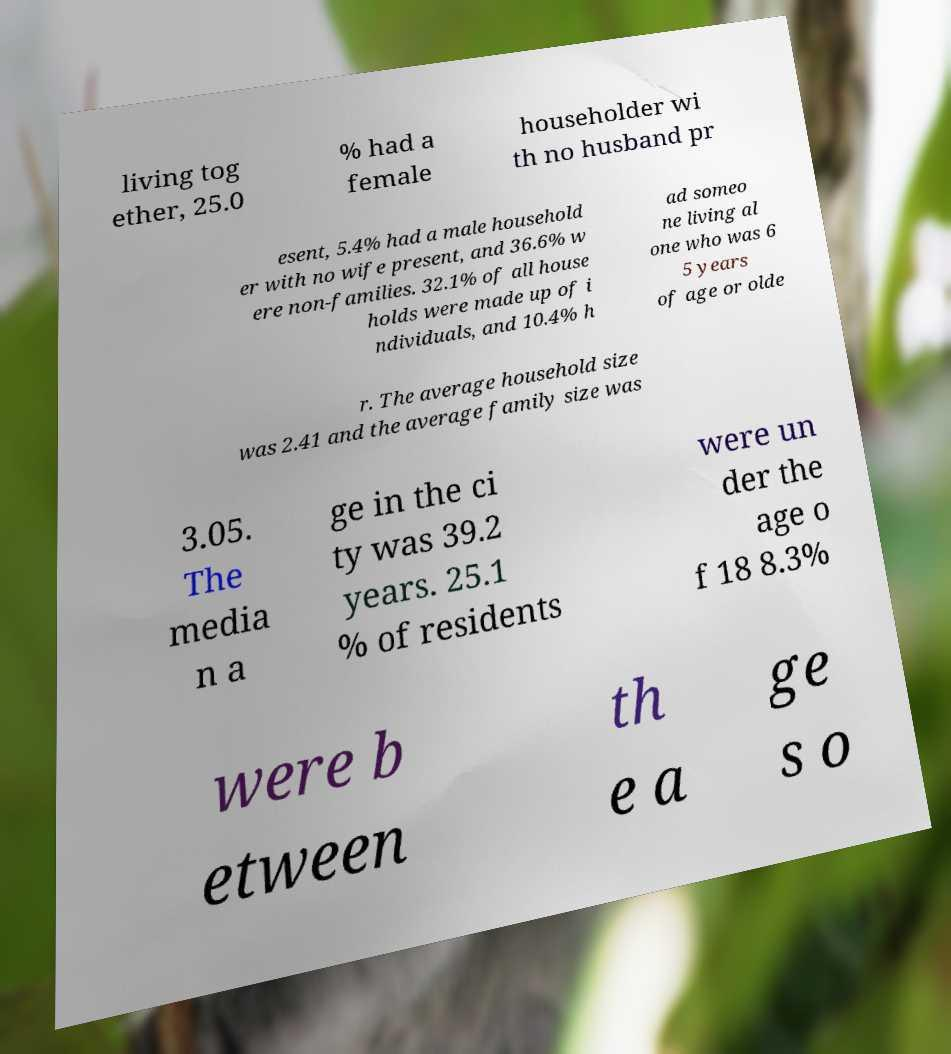I need the written content from this picture converted into text. Can you do that? living tog ether, 25.0 % had a female householder wi th no husband pr esent, 5.4% had a male household er with no wife present, and 36.6% w ere non-families. 32.1% of all house holds were made up of i ndividuals, and 10.4% h ad someo ne living al one who was 6 5 years of age or olde r. The average household size was 2.41 and the average family size was 3.05. The media n a ge in the ci ty was 39.2 years. 25.1 % of residents were un der the age o f 18 8.3% were b etween th e a ge s o 